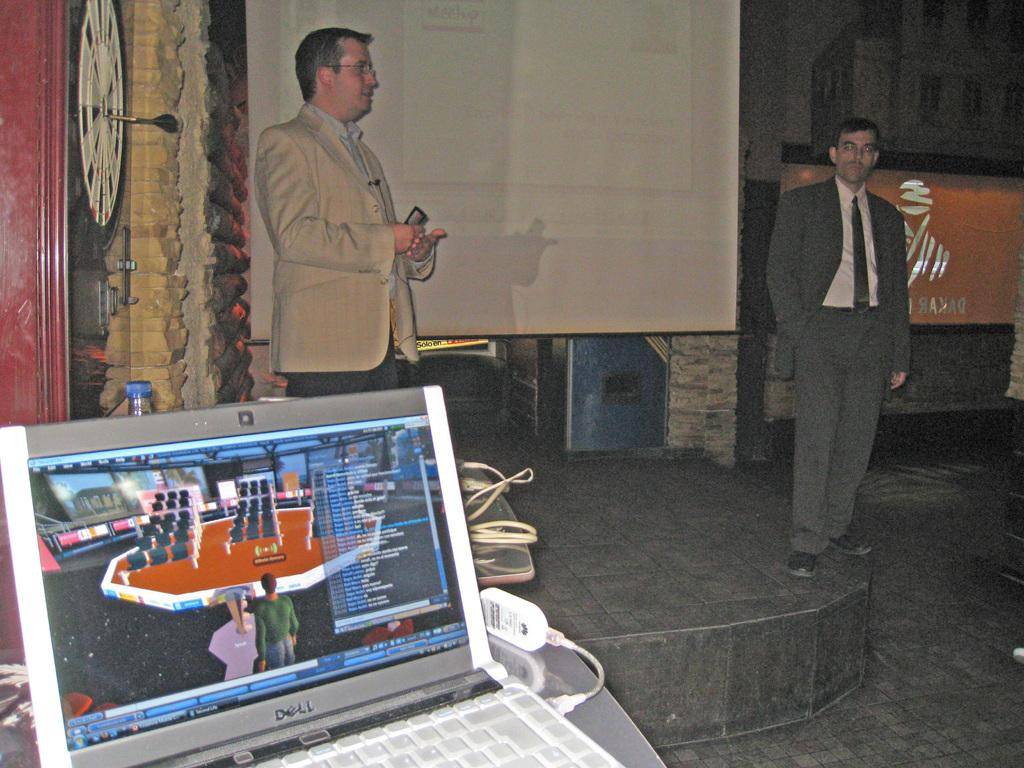What object is located on the left side of the image? There is a laptop on the left side of the image. What is happening in the middle of the image? A man is standing in the middle of the image. Can you describe the man in the middle? The man in the middle is wearing a coat. What is happening on the right side of the image? Another man is standing on the right side of the image. Can you describe the man on the right side? The man on the right side is wearing a tie and shoes. What type of harbor can be seen in the image? There is no harbor present in the image. What arithmetic problem is the man on the right side of the image solving? There is no indication of any arithmetic problem being solved in the image. 